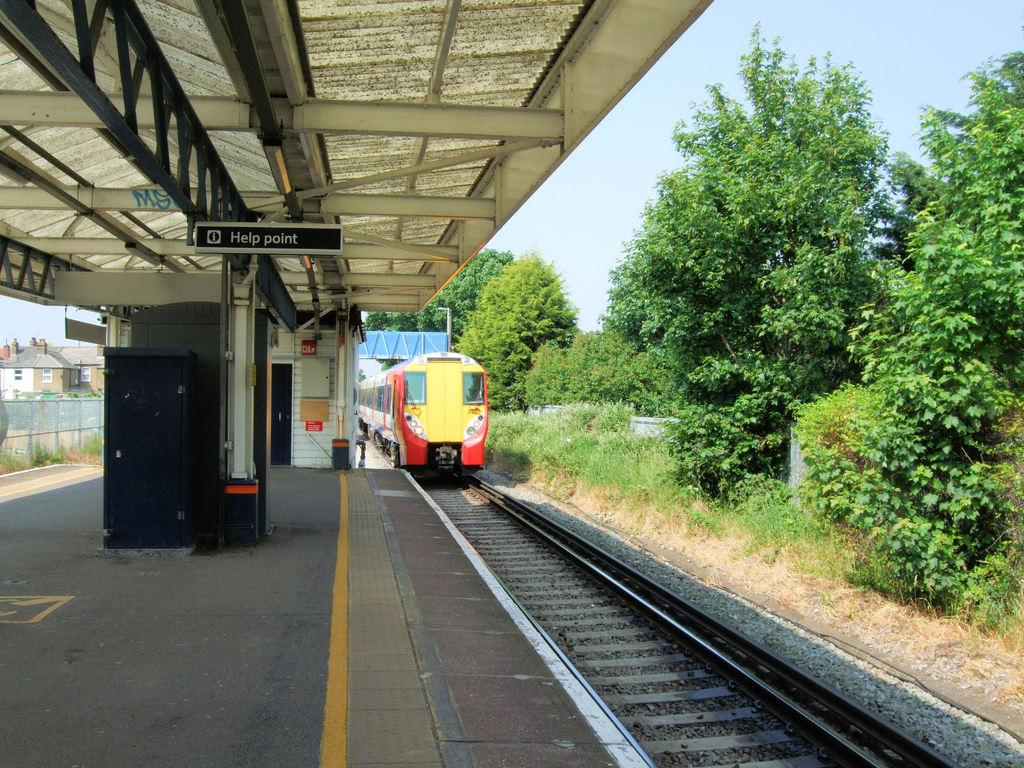Provide a one-sentence caption for the provided image. A sign designates the area as the "Help Point.". 